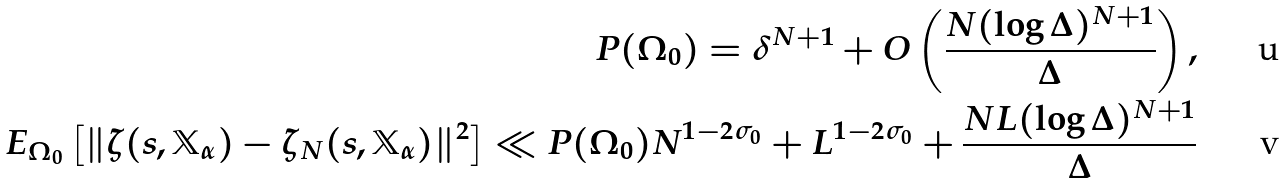Convert formula to latex. <formula><loc_0><loc_0><loc_500><loc_500>P ( \Omega _ { 0 } ) = \delta ^ { N + 1 } + O \left ( \frac { N ( \log { \Delta } ) ^ { N + 1 } } { \Delta } \right ) , \\ E _ { \Omega _ { 0 } } \left [ \| \zeta ( s , \mathbb { X } _ { \alpha } ) - \zeta _ { N } ( s , \mathbb { X } _ { \alpha } ) \| ^ { 2 } \right ] \ll P ( \Omega _ { 0 } ) N ^ { 1 - 2 \sigma _ { 0 } } + L ^ { 1 - 2 \sigma _ { 0 } } + \frac { N L ( \log { \Delta } ) ^ { N + 1 } } { \Delta }</formula> 